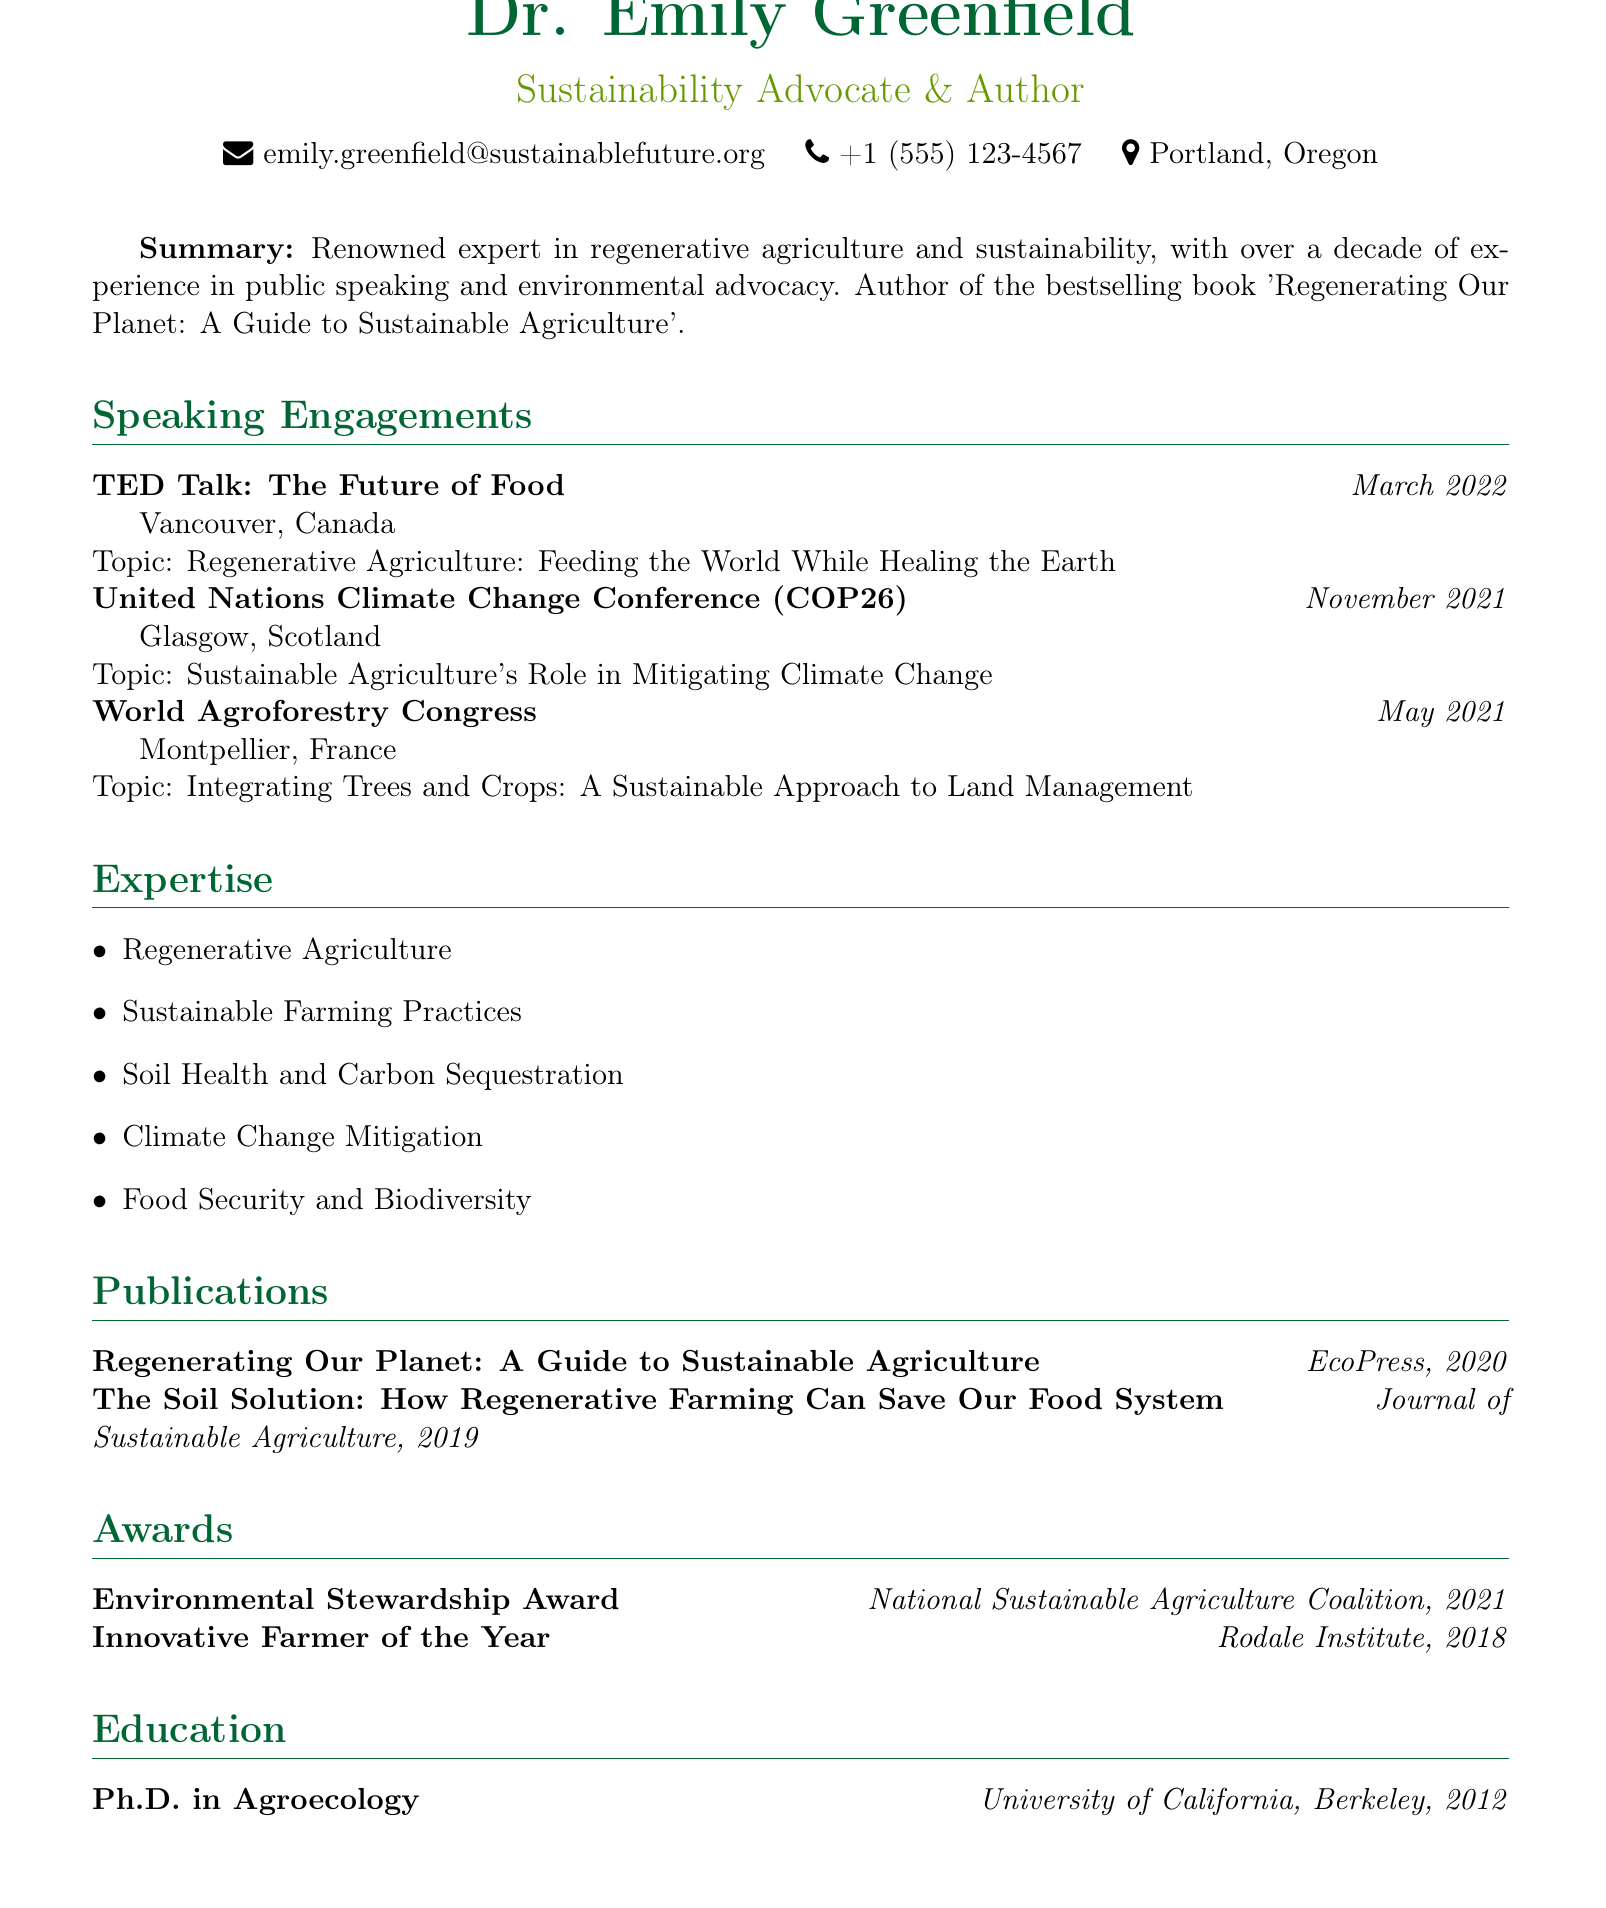What is Dr. Emily Greenfield's title? The title listed in the document is "Sustainability Advocate & Author."
Answer: Sustainability Advocate & Author When did Dr. Emily Greenfield give her TED Talk? The TED Talk was given in March 2022, as stated in the speaking engagements section.
Answer: March 2022 Which award did Dr. Greenfield receive in 2021? The document mentions the "Environmental Stewardship Award" received in 2021.
Answer: Environmental Stewardship Award What is one of Dr. Greenfield’s areas of expertise? The document lists several areas of expertise, including "Regenerative Agriculture."
Answer: Regenerative Agriculture Where did Dr. Greenfield complete her Ph.D.? The education section specifies that she received her Ph.D. from the "University of California, Berkeley."
Answer: University of California, Berkeley What was the topic of Dr. Greenfield's presentation at COP26? The document states the topic as "Sustainable Agriculture's Role in Mitigating Climate Change."
Answer: Sustainable Agriculture's Role in Mitigating Climate Change How many speaking engagements are listed in the document? There are three speaking engagements mentioned in the document.
Answer: 3 Which publication is authored by Dr. Greenfield? The document lists "Regenerating Our Planet: A Guide to Sustainable Agriculture" as a publication by Dr. Greenfield.
Answer: Regenerating Our Planet: A Guide to Sustainable Agriculture In what year did Dr. Greenfield receive the "Innovative Farmer of the Year" award? The document indicates that this award was received in 2018.
Answer: 2018 